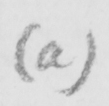What text is written in this handwritten line? (a) 